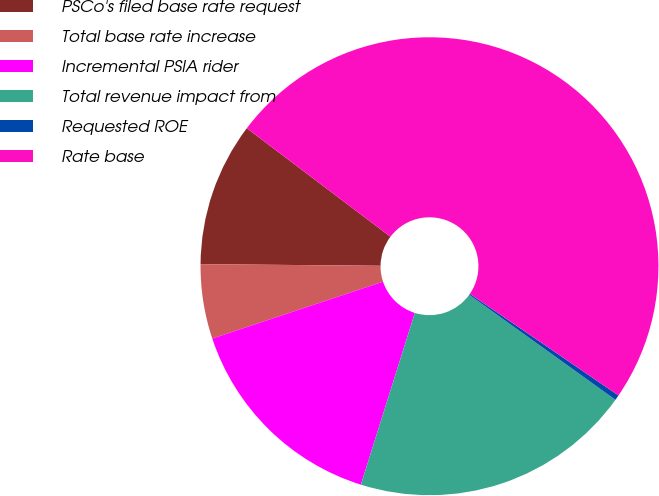Convert chart to OTSL. <chart><loc_0><loc_0><loc_500><loc_500><pie_chart><fcel>PSCo's filed base rate request<fcel>Total base rate increase<fcel>Incremental PSIA rider<fcel>Total revenue impact from<fcel>Requested ROE<fcel>Rate base<nl><fcel>10.15%<fcel>5.26%<fcel>15.04%<fcel>19.93%<fcel>0.37%<fcel>49.25%<nl></chart> 